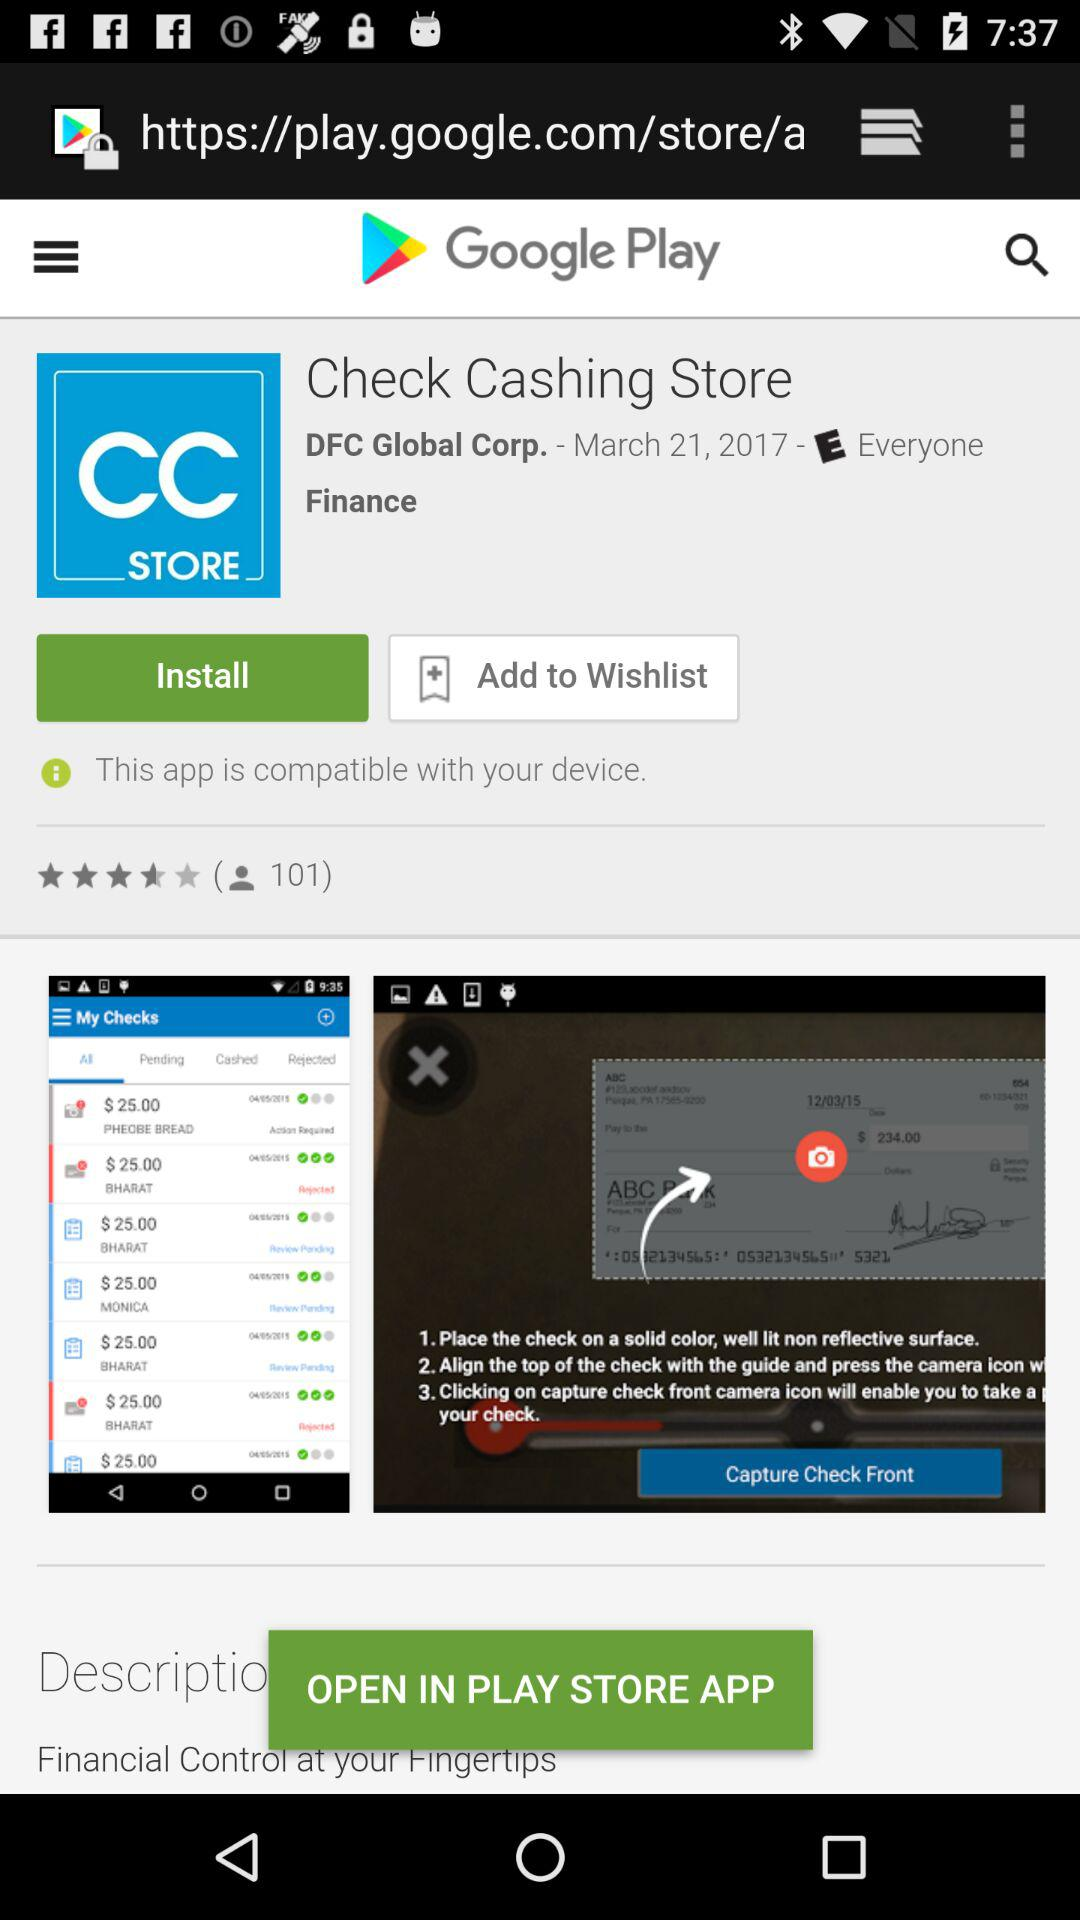Check cashing store is related to which category?
When the provided information is insufficient, respond with <no answer>. <no answer> 